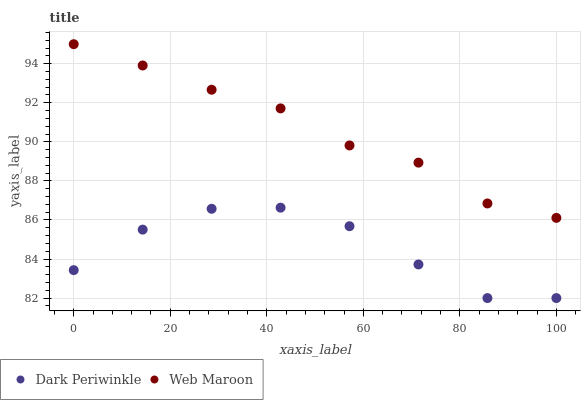Does Dark Periwinkle have the minimum area under the curve?
Answer yes or no. Yes. Does Web Maroon have the maximum area under the curve?
Answer yes or no. Yes. Does Dark Periwinkle have the maximum area under the curve?
Answer yes or no. No. Is Web Maroon the smoothest?
Answer yes or no. Yes. Is Dark Periwinkle the roughest?
Answer yes or no. Yes. Is Dark Periwinkle the smoothest?
Answer yes or no. No. Does Dark Periwinkle have the lowest value?
Answer yes or no. Yes. Does Web Maroon have the highest value?
Answer yes or no. Yes. Does Dark Periwinkle have the highest value?
Answer yes or no. No. Is Dark Periwinkle less than Web Maroon?
Answer yes or no. Yes. Is Web Maroon greater than Dark Periwinkle?
Answer yes or no. Yes. Does Dark Periwinkle intersect Web Maroon?
Answer yes or no. No. 